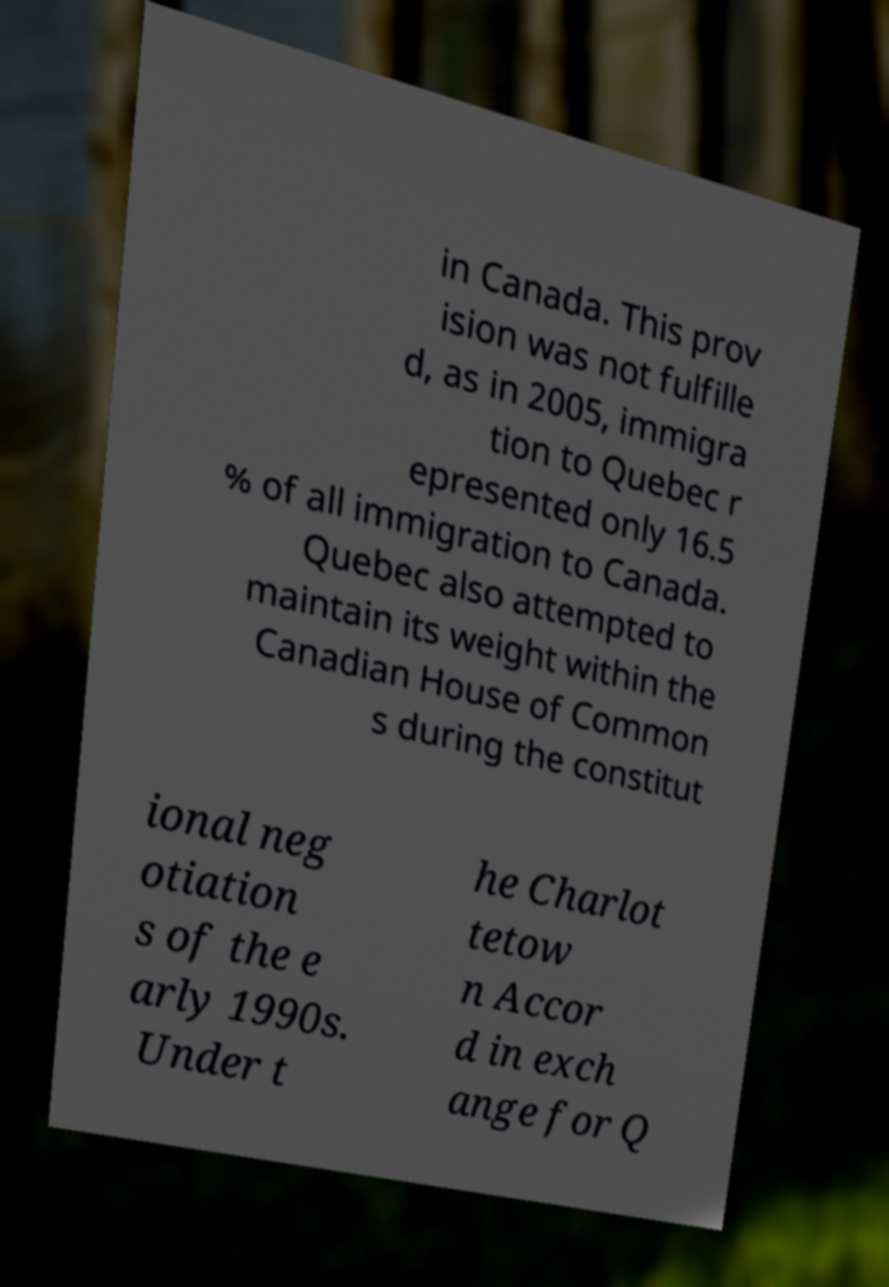What messages or text are displayed in this image? I need them in a readable, typed format. in Canada. This prov ision was not fulfille d, as in 2005, immigra tion to Quebec r epresented only 16.5 % of all immigration to Canada. Quebec also attempted to maintain its weight within the Canadian House of Common s during the constitut ional neg otiation s of the e arly 1990s. Under t he Charlot tetow n Accor d in exch ange for Q 